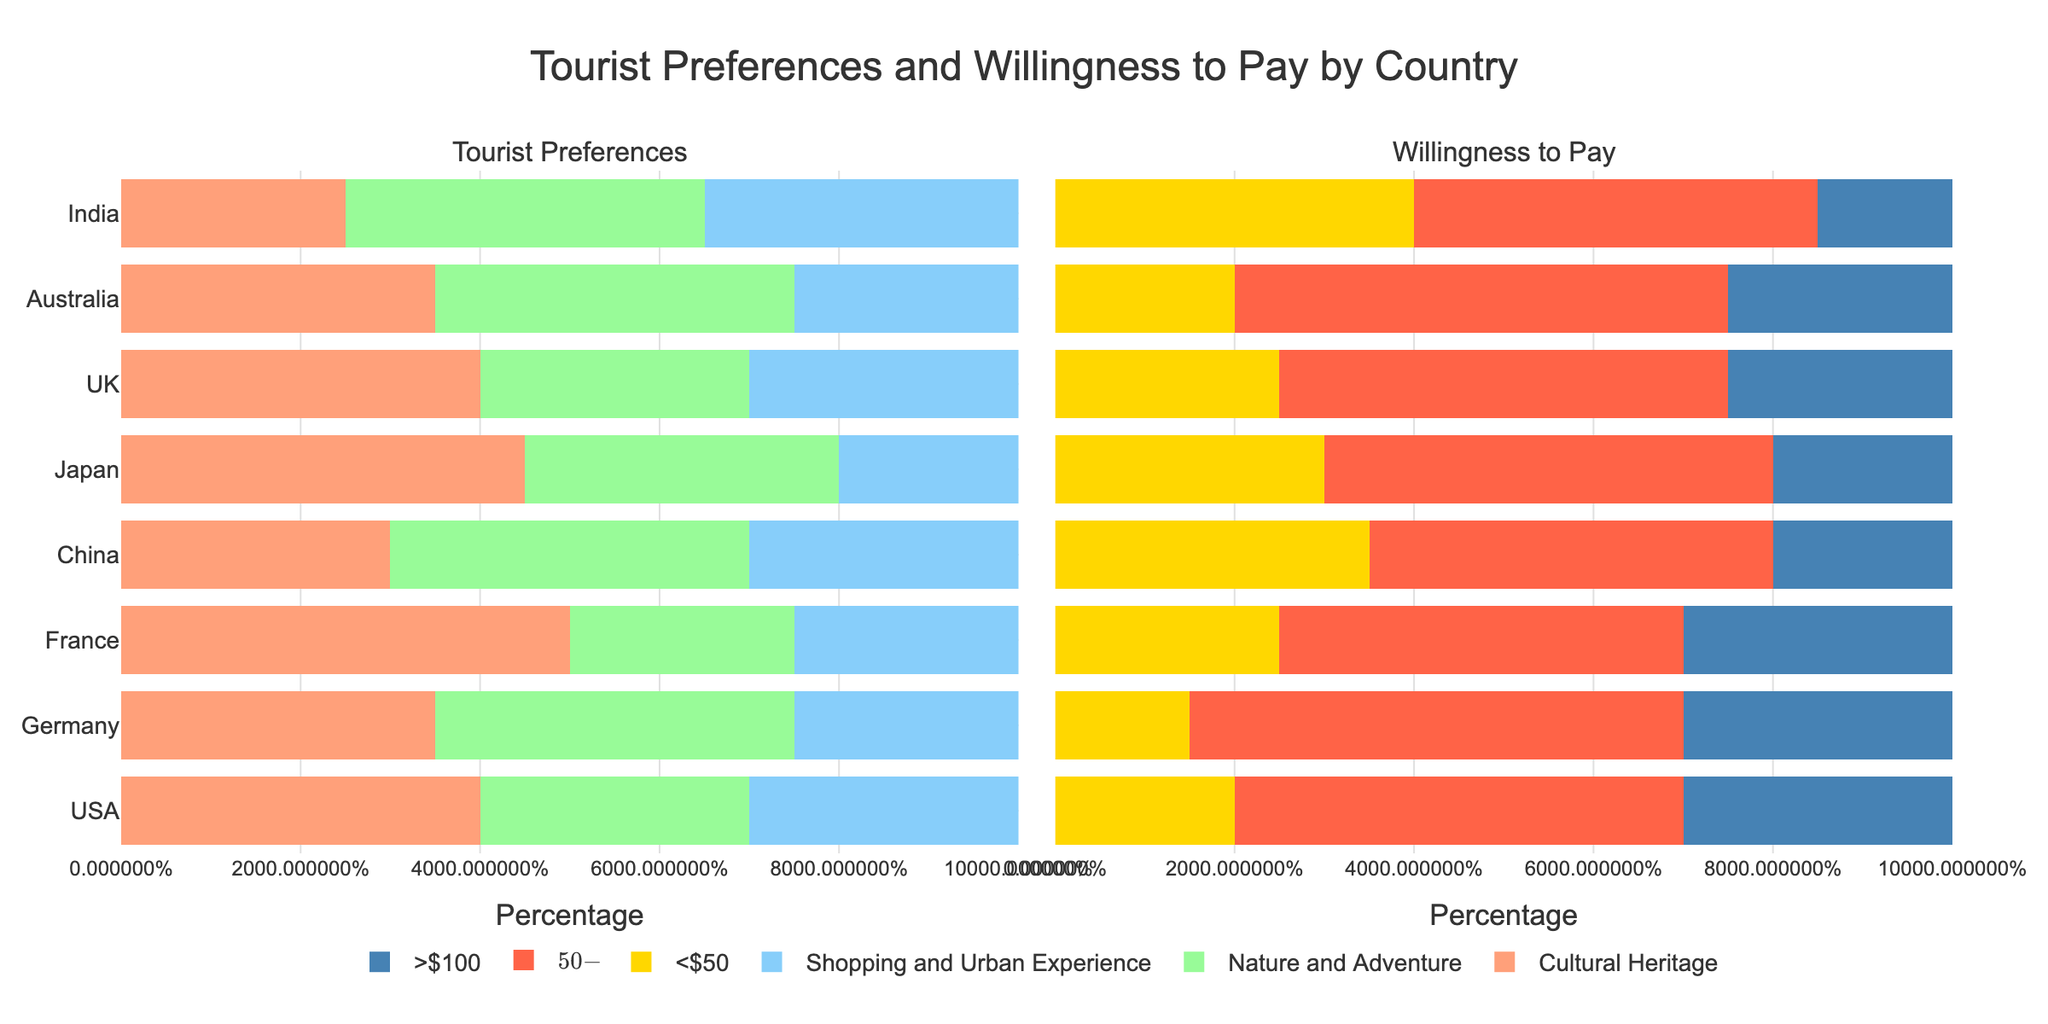Which country has the highest preference for cultural heritage? By examining the bar lengths on the preferences subplot, the country with the tallest bar for "Preference for Cultural Heritage" determines the answer. France has the highest preference for cultural heritage at 50%.
Answer: France Among the countries, which has the lowest willingness to pay more than $100? Check the lengths of the bars representing the willingness to pay >$100 on the second subplot. The country with the shortest bar is India with 15%.
Answer: India Compare the overall preferences for nature and adventure between Germany and China. Which one is higher? Look at the bars for "Preference for Nature and Adventure" for both Germany and China in the preferences subplot. Germany's bar is slightly shorter than China's, indicating that China has a higher preference (40% vs. 40%).
Answer: China Among the countries surveyed, which has a balanced preference for cultural heritage, nature, and adventure, and shopping and urban experience? Search for countries where the bars for all three preference categories are similar in length. The USA has the bars for all three preferences roughly the same length (40%, 30%, 30%).
Answer: USA What’s the sum of the preferences for nature and adventure and shopping and urban experience for tourists from India? Add the percentages for India's preferences for nature and adventure (40%) and shopping and urban experience (35%). Sum = 40% + 35% = 75%.
Answer: 75% Which country shows the highest percentage of tourists willing to pay $50-$100? Identify the country with the longest bar in the "<$50-$100" category. Australia and Germany both have 55%, but Germany comes first alphabetically.
Answer: Germany What is the total percentage of tourists from the UK willing to pay more than $100 and $50-$100 combined? Add the percentages of willingness to pay >$100 (25%) and $50-$100 (50%) for the UK. Total = 25% + 50% = 75%.
Answer: 75% How does Japan's preference for shopping and urban experiences compare to its preference for nature and adventure? Compare the bar lengths for Japan's "Preference for Shopping and Urban Experience" (20%) and "Preference for Nature and Adventure" (35%) on the preferences subplot. Nature and adventure have a higher percentage (35% vs. 20%).
Answer: Nature and adventure For which country is the difference between the preferences for cultural heritage and shopping and urban experiences the greatest? Calculate the absolute differences between the preference bars for cultural heritage and shopping and urban experiences for each country. France has the greatest difference: 50% (cultural heritage) - 25% (shopping) = 25%.
Answer: France 